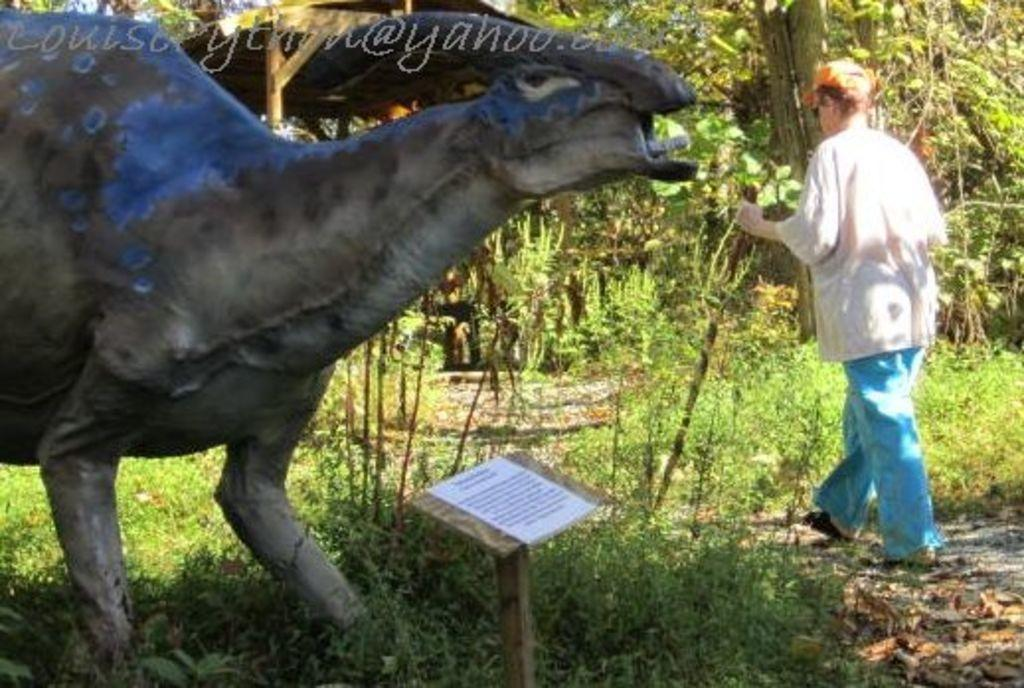What is located on the left side of the image? There is an unknown creature on the left side of the image. What is happening on the right side of the image? There is an old woman walking on the right side of the image. What object can be found at the bottom of the image? There is a book at the bottom of the image. How does the unknown creature affect the society in the image? There is no information about the creature's impact on society in the image, as it only shows the creature and the old woman walking. What type of waves can be seen in the image? There are no waves present in the image; it features an unknown creature, an old woman walking, and a book. 